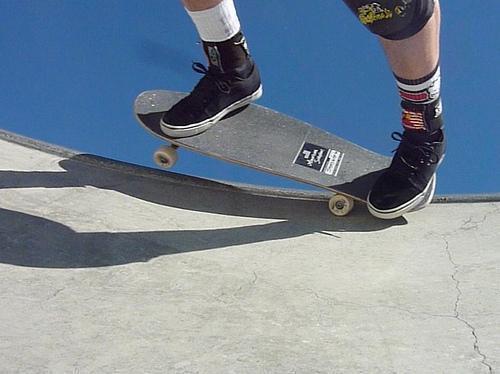How many people are there?
Give a very brief answer. 1. How many shoes are there?
Give a very brief answer. 2. 